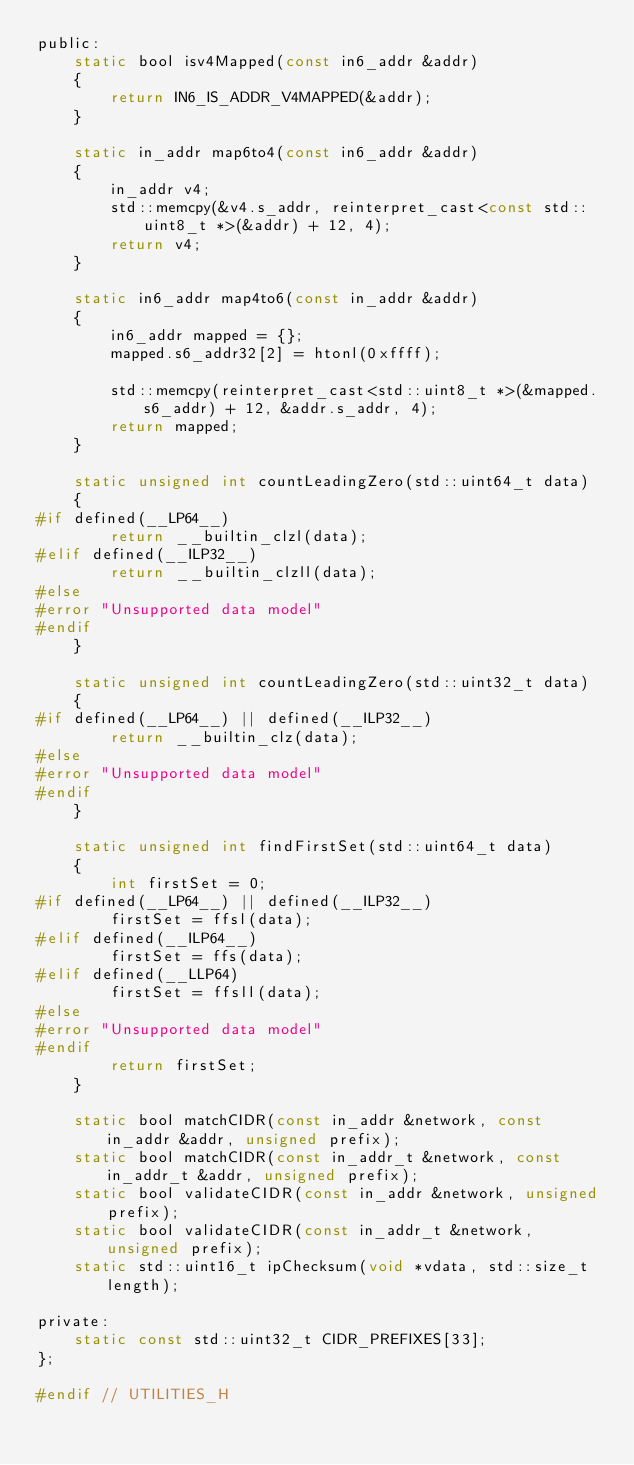Convert code to text. <code><loc_0><loc_0><loc_500><loc_500><_C_>public:
    static bool isv4Mapped(const in6_addr &addr)
    {
        return IN6_IS_ADDR_V4MAPPED(&addr);
    }

    static in_addr map6to4(const in6_addr &addr)
    {
        in_addr v4;
        std::memcpy(&v4.s_addr, reinterpret_cast<const std::uint8_t *>(&addr) + 12, 4);
        return v4;
    }

    static in6_addr map4to6(const in_addr &addr)
    {
        in6_addr mapped = {};
        mapped.s6_addr32[2] = htonl(0xffff);

        std::memcpy(reinterpret_cast<std::uint8_t *>(&mapped.s6_addr) + 12, &addr.s_addr, 4);
        return mapped;
    }

    static unsigned int countLeadingZero(std::uint64_t data)
    {
#if defined(__LP64__)
        return __builtin_clzl(data);
#elif defined(__ILP32__)
        return __builtin_clzll(data);
#else
#error "Unsupported data model"
#endif
    }

    static unsigned int countLeadingZero(std::uint32_t data)
    {
#if defined(__LP64__) || defined(__ILP32__)
        return __builtin_clz(data);
#else
#error "Unsupported data model"
#endif
    }

    static unsigned int findFirstSet(std::uint64_t data)
    {
        int firstSet = 0;
#if defined(__LP64__) || defined(__ILP32__)
        firstSet = ffsl(data);
#elif defined(__ILP64__)
        firstSet = ffs(data);
#elif defined(__LLP64)
        firstSet = ffsll(data);
#else
#error "Unsupported data model"
#endif
        return firstSet;
    }

    static bool matchCIDR(const in_addr &network, const in_addr &addr, unsigned prefix);
    static bool matchCIDR(const in_addr_t &network, const in_addr_t &addr, unsigned prefix);
    static bool validateCIDR(const in_addr &network, unsigned prefix);
    static bool validateCIDR(const in_addr_t &network, unsigned prefix);
    static std::uint16_t ipChecksum(void *vdata, std::size_t length);

private:
    static const std::uint32_t CIDR_PREFIXES[33];
};

#endif // UTILITIES_H
</code> 